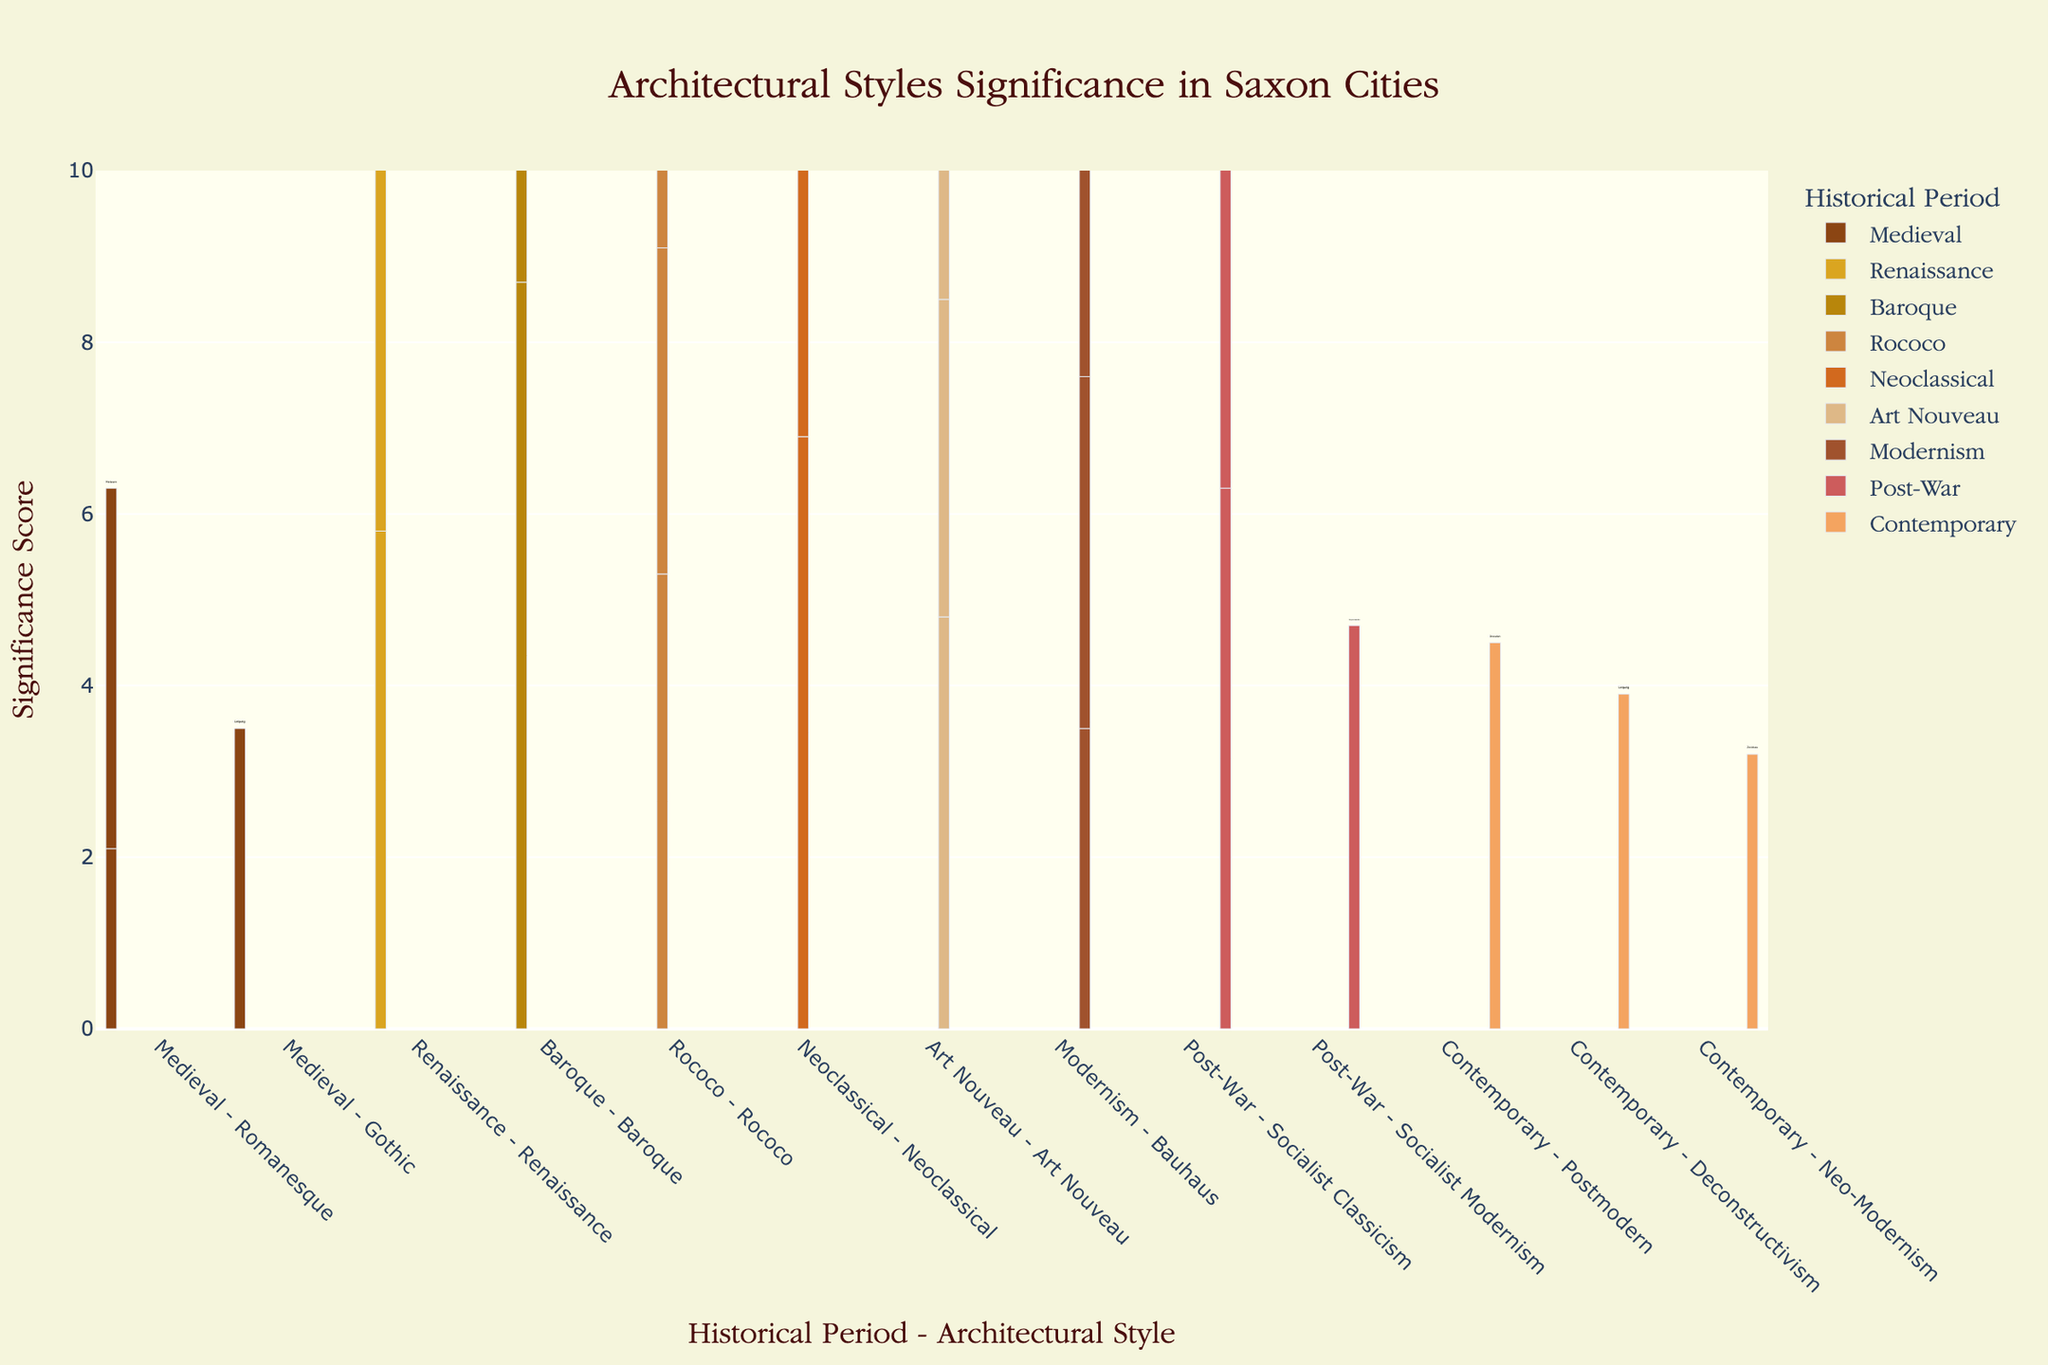What's the highest Significance Score for Baroque architecture? Looking at the bar for Baroque, Dresden has the highest significance score of 8.7.
Answer: 8.7 Which period has the most significant architecture in Dresden? Comparing the bars for Dresden across all periods, Baroque period has the highest score with 8.7.
Answer: Baroque Compare the significance scores of Neoclassical architecture between Dresden and Leipzig. Which one is higher? Dresden's Neoclassical architecture has a significance score of 6.9 while Leipzig's score is 5.6. Dresden is higher.
Answer: Dresden What is the sum of the significance scores for Rococo architecture across all cities? Adding the Rococo scores: 5.3 (Dresden) + 3.8 (Leipzig) + 6.1 (Pillnitz) = 15.2.
Answer: 15.2 Identify the period-architecture pair with the lowest significance score. The lowest significance score in the plot is for Art Nouveau in Plauen with a score of 2.9.
Answer: Art Nouveau in Plauen Which period has the most significant architectural style in Leipzig? By comparing significance scores for Leipzig across periods, Baroque stands out with a score of 6.2.
Answer: Baroque Calculate the average significance score for Modernism across all cities. Summing the scores for Modernism: 3.5 (Dresden) + 4.1 (Leipzig) + 5.2 (Chemnitz) = 12.8. Average = 12.8 / 3 = 4.27.
Answer: 4.27 Which city appears the most often across all periods and architectural styles? By counting the occurrences, Dresden appears most often across all periods and styles.
Answer: Dresden Compare the significance scores for Renaissance architecture across all cities. Which city has the highest score? Comparing the Renaissance scores, Dresden has the highest with a score of 5.8.
Answer: Dresden 